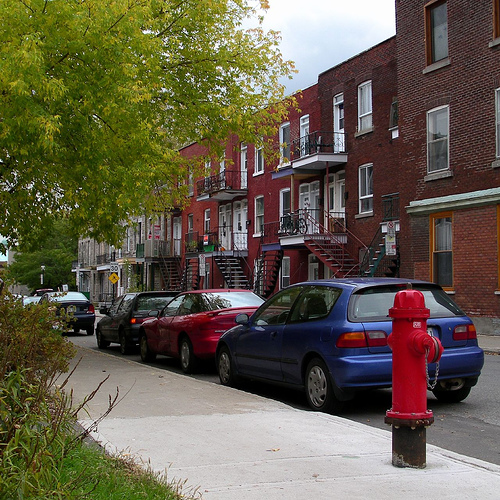<image>From where is the smoke coming? There is no smoke in the image. It can't be determined where it's coming from. From where is the smoke coming? I don't know from where the smoke is coming. There is no smoke visible in the image. 